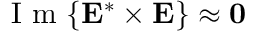<formula> <loc_0><loc_0><loc_500><loc_500>I m \{ E ^ { * } \times E \} \approx 0</formula> 